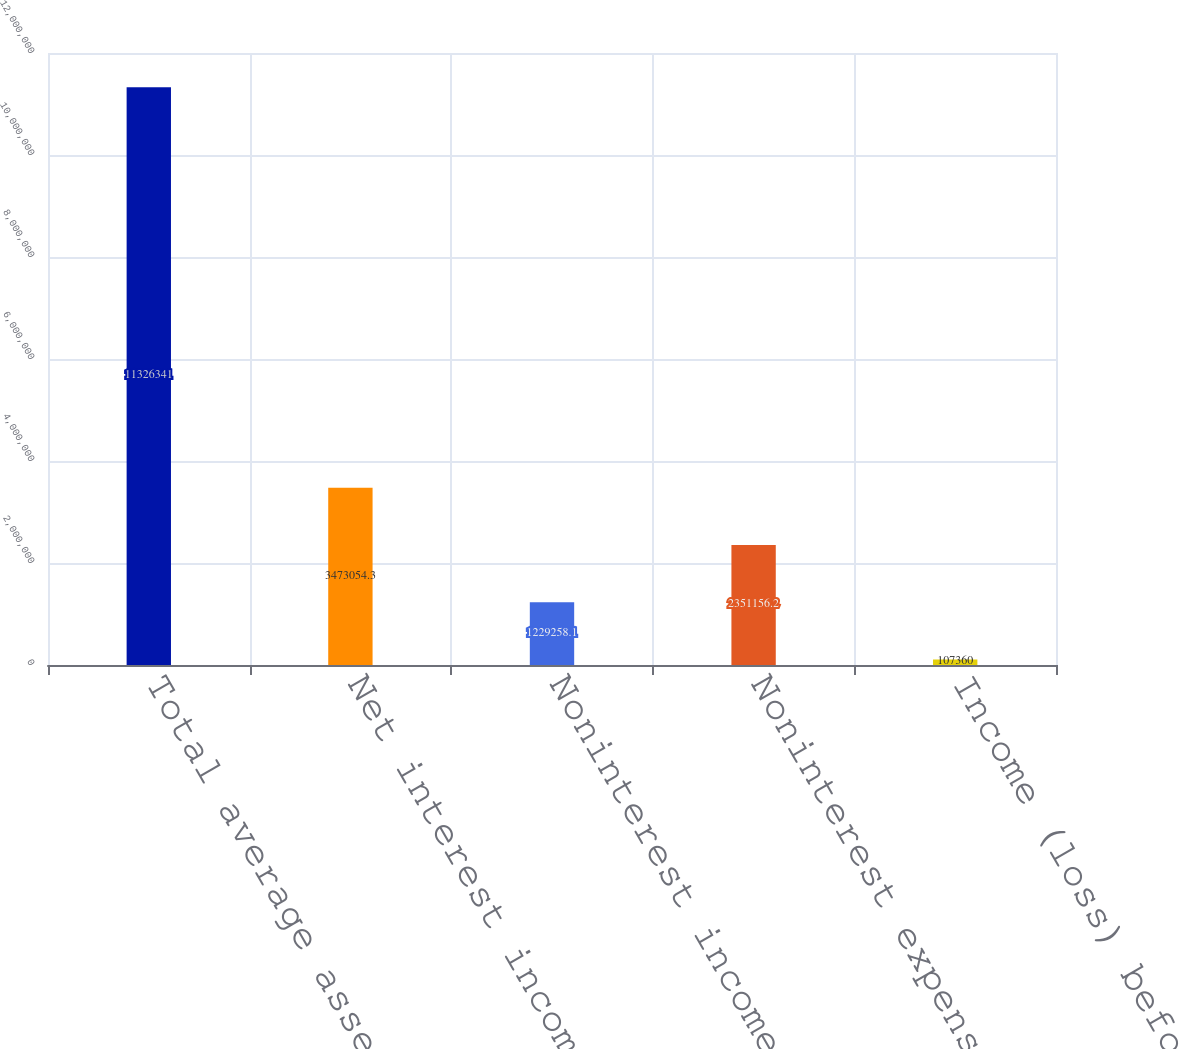<chart> <loc_0><loc_0><loc_500><loc_500><bar_chart><fcel>Total average assets<fcel>Net interest income (loss)<fcel>Noninterest income<fcel>Noninterest expense (2)<fcel>Income (loss) before income<nl><fcel>1.13263e+07<fcel>3.47305e+06<fcel>1.22926e+06<fcel>2.35116e+06<fcel>107360<nl></chart> 